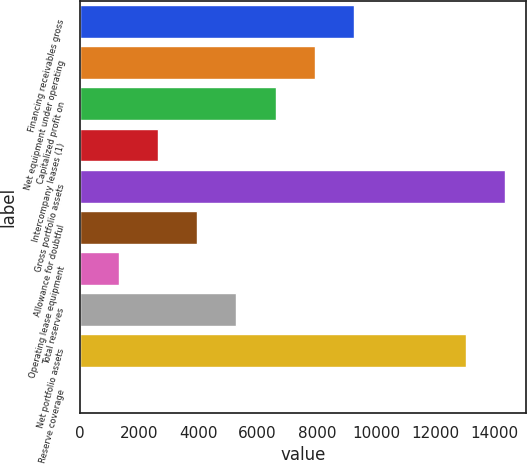Convert chart. <chart><loc_0><loc_0><loc_500><loc_500><bar_chart><fcel>Financing receivables gross<fcel>Net equipment under operating<fcel>Capitalized profit on<fcel>Intercompany leases (1)<fcel>Gross portfolio assets<fcel>Allowance for doubtful<fcel>Operating lease equipment<fcel>Total reserves<fcel>Net portfolio assets<fcel>Reserve coverage<nl><fcel>9253.02<fcel>7931.36<fcel>6609.7<fcel>2644.72<fcel>14348.7<fcel>3966.38<fcel>1323.06<fcel>5288.04<fcel>13027<fcel>1.4<nl></chart> 